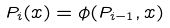Convert formula to latex. <formula><loc_0><loc_0><loc_500><loc_500>P _ { i } ( x ) = \phi ( P _ { i - 1 } , x )</formula> 